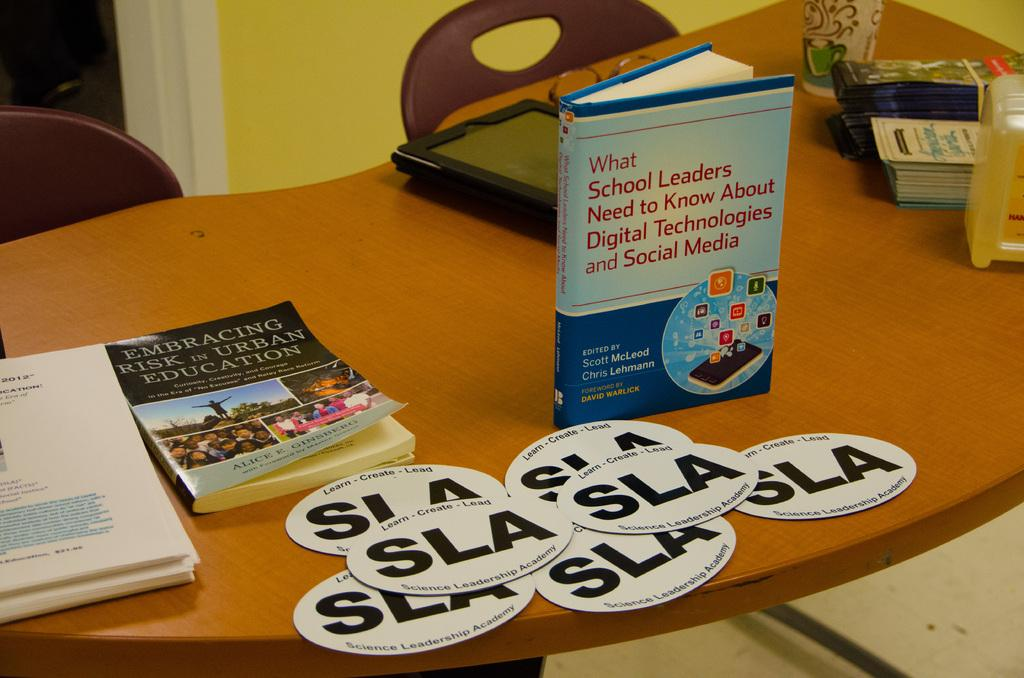<image>
Give a short and clear explanation of the subsequent image. A copy of EMBRACING RISK IN URBAN EDUCATION sits on a table with some other things. 